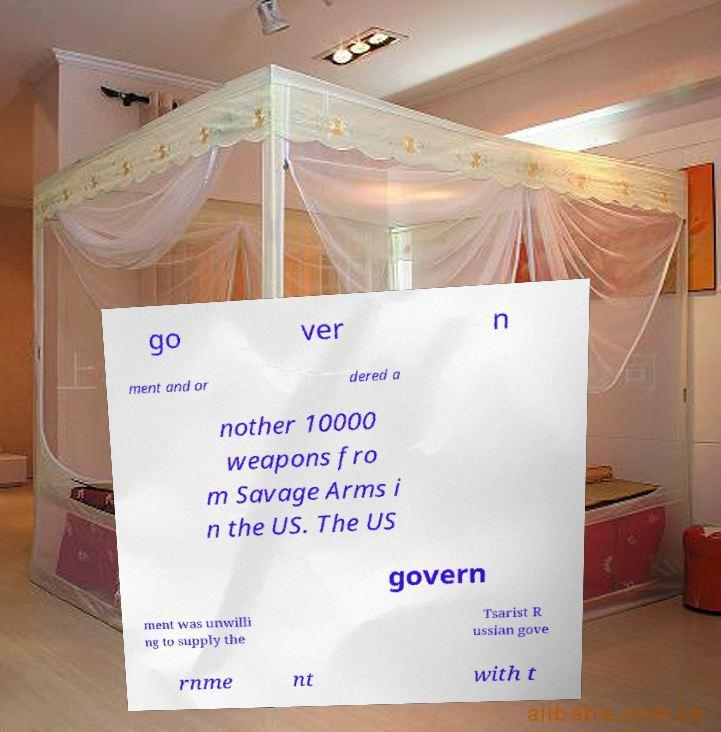I need the written content from this picture converted into text. Can you do that? go ver n ment and or dered a nother 10000 weapons fro m Savage Arms i n the US. The US govern ment was unwilli ng to supply the Tsarist R ussian gove rnme nt with t 